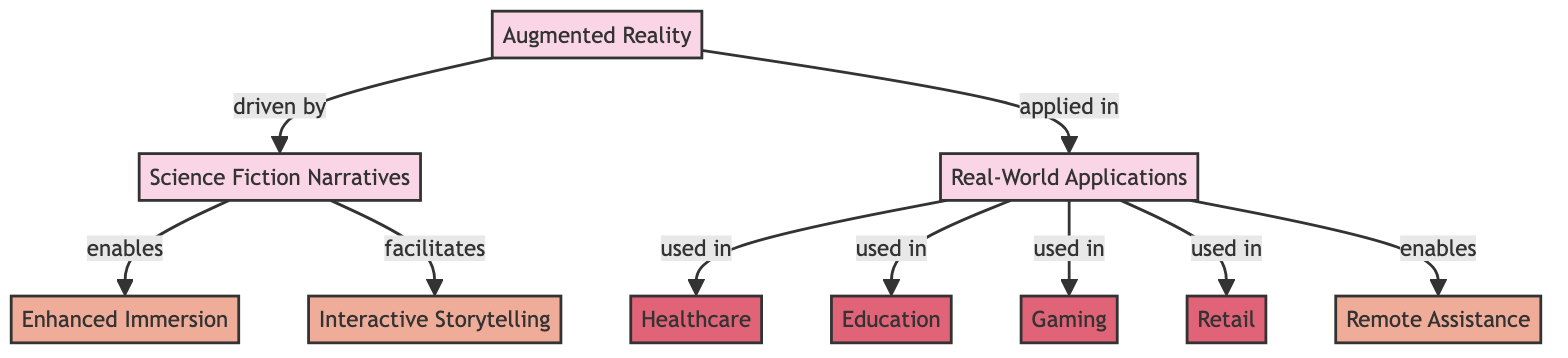What is the main concept depicted in the diagram? The main concept in the diagram is "Augmented Reality," as it is prominently labeled and rounded at the top of the diagram, signifying its central role.
Answer: Augmented Reality How many main concepts are illustrated in the diagram? There are three main concepts illustrated: "Augmented Reality," "Science Fiction Narratives," and "Real-World Applications." Each of these is shown as a highlighted node.
Answer: Three Which concept is directly driven by "Augmented Reality"? "Science Fiction Narratives" is directly driven by "Augmented Reality," as indicated by the arrow showing a connection with the label "driven by."
Answer: Science Fiction Narratives What type of feature does "Science Fiction Narratives" enable? "Science Fiction Narratives" enables "Enhanced Immersion," as denoted by the arrow labeled "enables" pointing towards that feature.
Answer: Enhanced Immersion Which industries utilize "Augmented Reality" according to the diagram? The industries utilizing "Augmented Reality" are "Healthcare," "Education," "Gaming," and "Retail," as shown with arrows leading from "Real-World Applications" to each industry node.
Answer: Healthcare, Education, Gaming, Retail What feature is associated with "Real-World Applications" that relates to assistance? The feature associated with assistance is "Remote Assistance," which is indicated by the arrow from "Real-World Applications" labeled "enables."
Answer: Remote Assistance How does "Science Fiction Narratives" relate to "Interactive Storytelling"? "Science Fiction Narratives" facilitates "Interactive Storytelling," as evidenced by the directional arrow labeled "facilitates" connecting the two nodes.
Answer: Facilitates Which feature is a common application of "Augmented Reality" in narratives? "Interactive Storytelling" is a common application of "Augmented Reality" in narratives, as shown by the connection with the label "facilitates."
Answer: Interactive Storytelling What is the relationship between "Real-World Applications" and "Gaming"? "Real-World Applications" is used in "Gaming," as shown by the arrow indicating the relationship with the label "used in."
Answer: Used in 